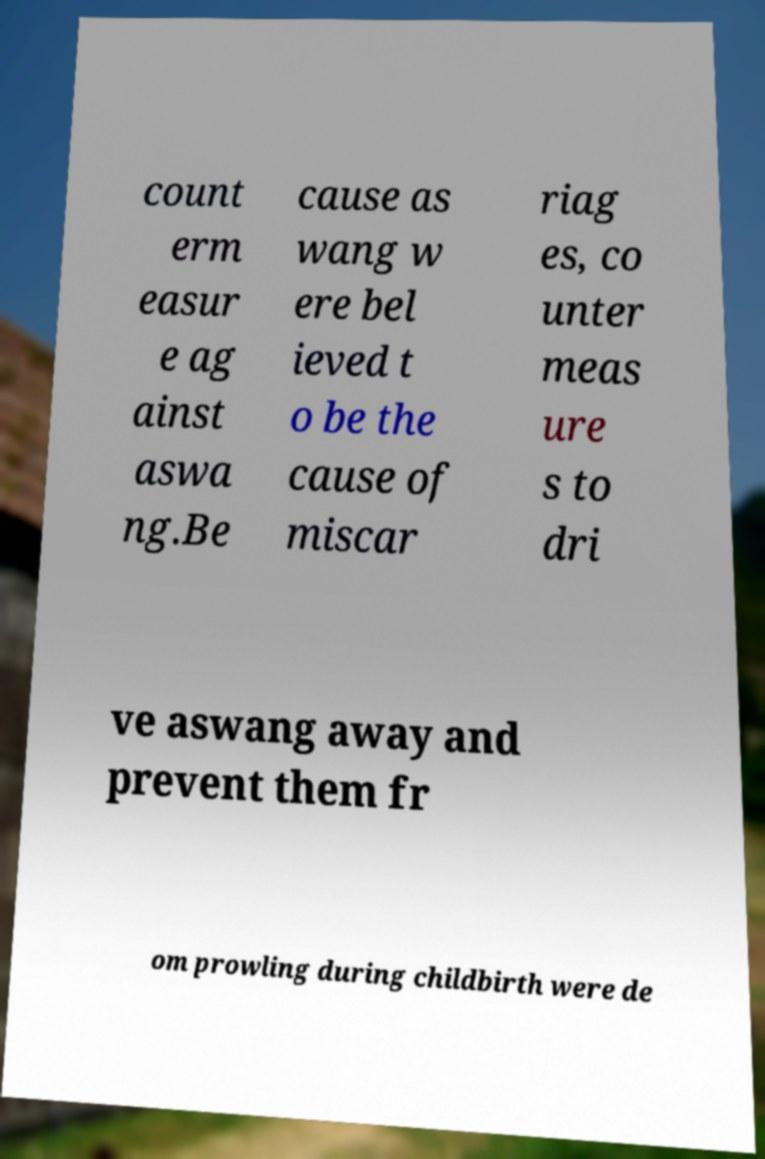Can you read and provide the text displayed in the image?This photo seems to have some interesting text. Can you extract and type it out for me? count erm easur e ag ainst aswa ng.Be cause as wang w ere bel ieved t o be the cause of miscar riag es, co unter meas ure s to dri ve aswang away and prevent them fr om prowling during childbirth were de 